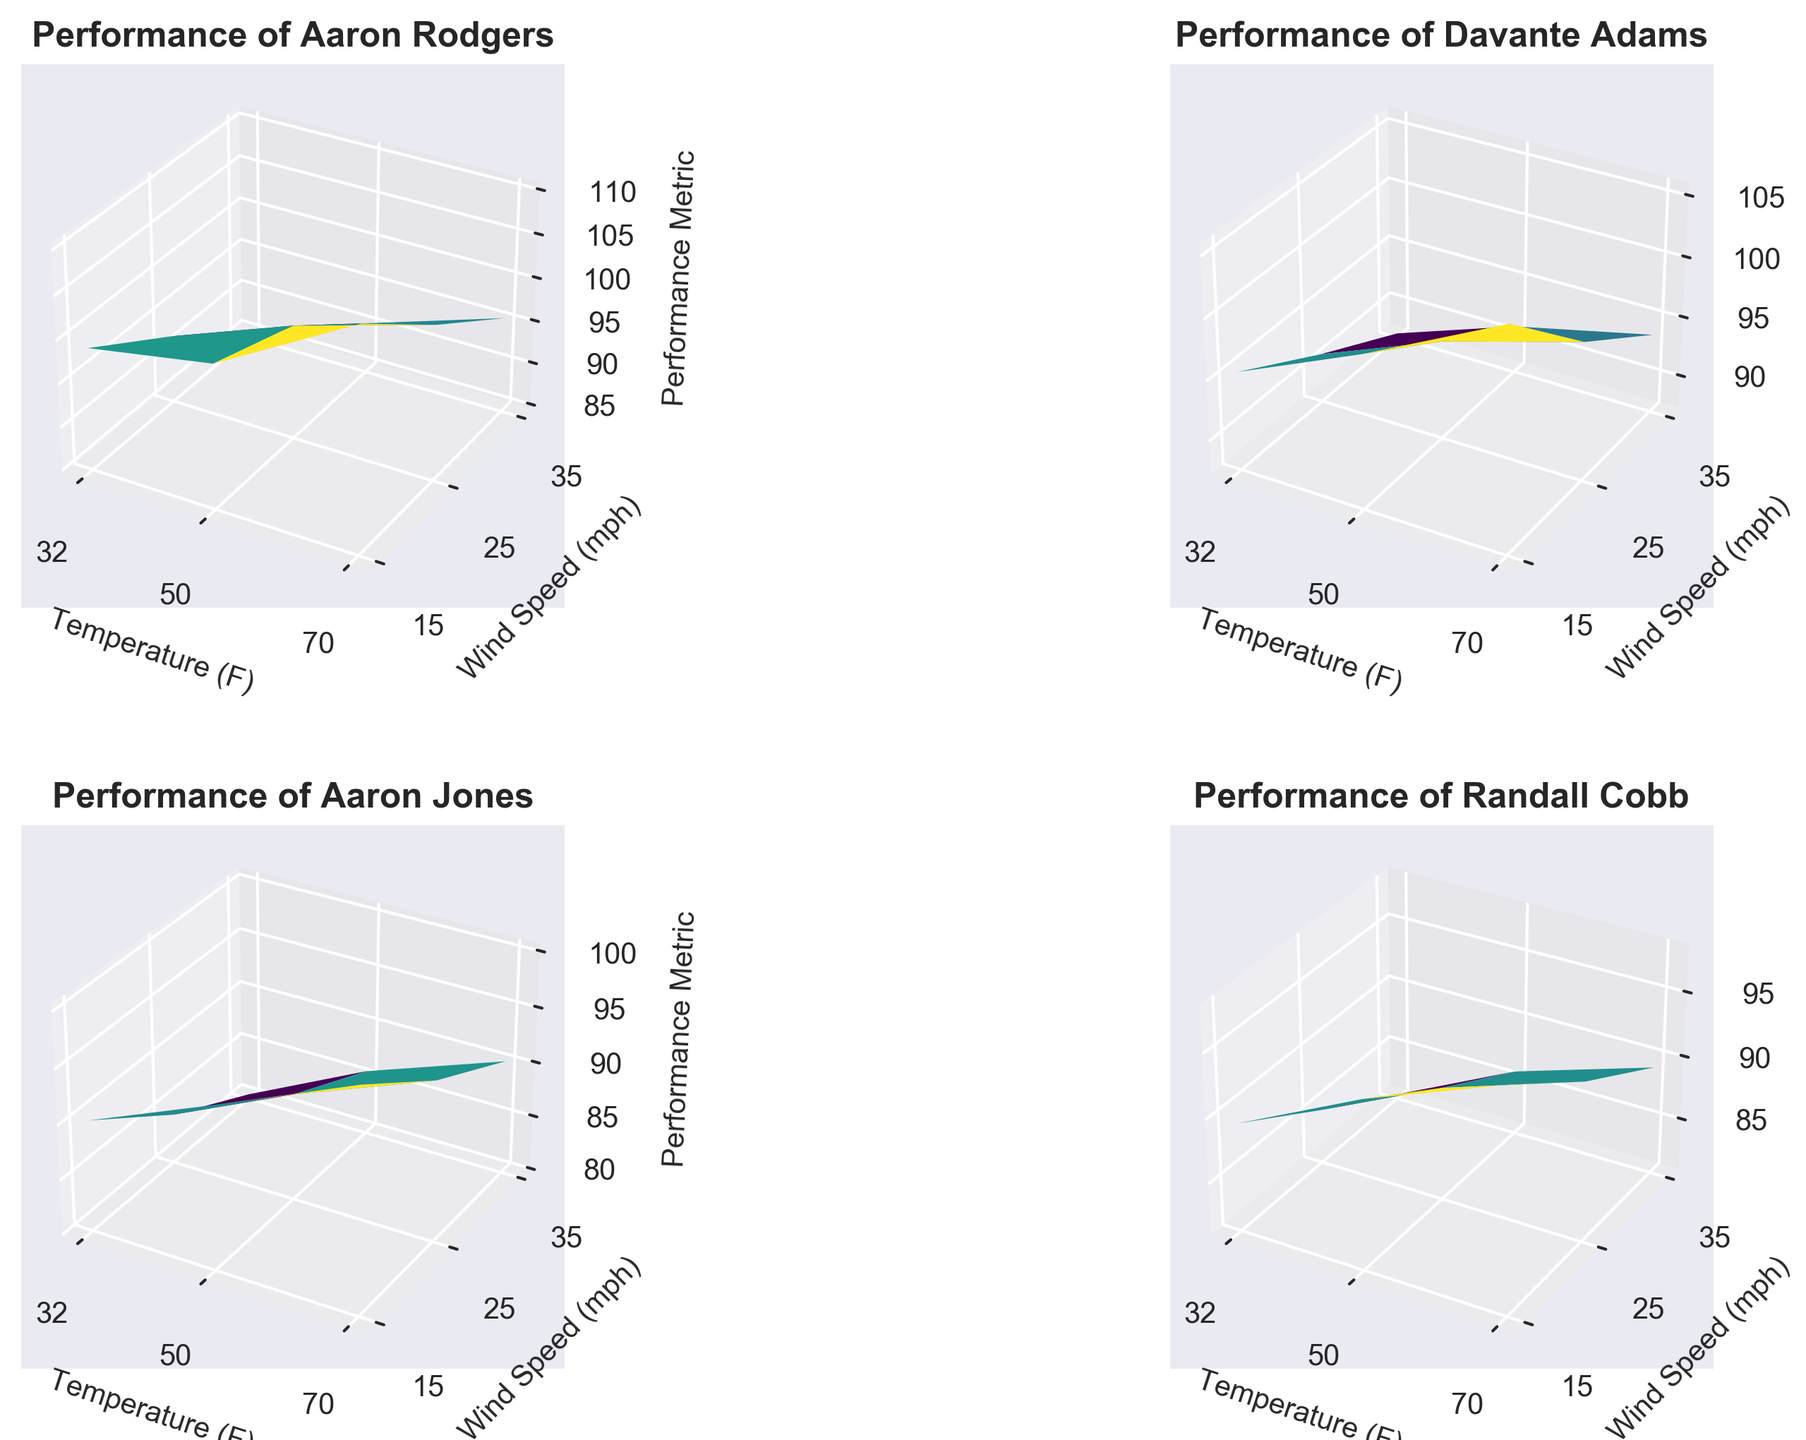What's the highest performance metric observed for Aaron Rodgers? Look at the 3D surface plot for Aaron Rodgers and identify the peak of the surface. The highest performance metric is represented by the tallest point on the plot.
Answer: 110.2 How does Aaron Jones' performance metric at 70°F and 35 mph wind compare to his performance at 50°F and 35 mph wind? Compare the height of the surface at these two coordinates (70°F & 35 mph and 50°F & 35 mph) on Aaron Jones' plot. The height represents the performance metric.
Answer: Higher at 70°F and 35 mph Which player shows the greatest decline in performance metric from 15 mph to 35 mph wind speed at 32°F? Compare the decline in performance metric across the players' plots. Look for the steepest drop between 15 mph and 35 mph at 32°F for each player.
Answer: Aaron Jones For temperatures at 70°F, which player has the highest average performance metric across different wind speeds? Calculate the average of the performance metrics for each player at 70°F across all wind speeds. Compare these averages to find the highest one.
Answer: Aaron Rodgers Which player shows the least variability in performance metric at 32°F across different wind speeds? Look at the surface plots' shapes for each player at 32°F. Identify the player whose performance metric remains most consistent (smallest height variation) across different wind speeds.
Answer: Davante Adams At 50°F and a wind speed of 25 mph, whose performance metric is better: Randall Cobb or Aaron Rodgers? Compare the heights of the points at 50°F and 25 mph wind speed for Randall Cobb and Aaron Rodgers on their respective plots.
Answer: Aaron Rodgers Does Davante Adams' performance improve or deteriorate as the wind speed increases from 15 mph to 35 mph at 70°F? Observe the change in height of the surface plot for Davante Adams at 70°F as you move from 15 mph to 35 mph.
Answer: Deteriorate At what temperature does Randall Cobb achieve his highest performance metric? Identify the peak point on Randall Cobb's surface plot and note the corresponding temperature axis value.
Answer: 70°F 